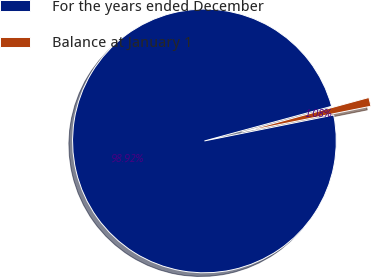Convert chart to OTSL. <chart><loc_0><loc_0><loc_500><loc_500><pie_chart><fcel>For the years ended December<fcel>Balance at January 1<nl><fcel>98.92%<fcel>1.08%<nl></chart> 